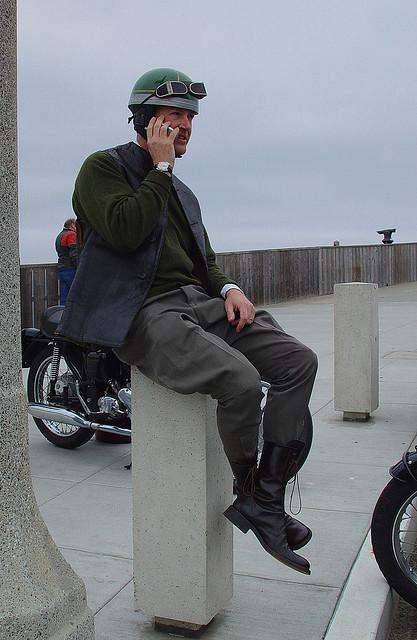The man sitting on the post with the phone to his ear is wearing what color of dome on his hat?

Choices:
A) red
B) blue
C) yellow
D) green green 